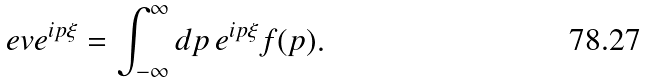Convert formula to latex. <formula><loc_0><loc_0><loc_500><loc_500>\ e v { e ^ { i p \xi } } = \int _ { - \infty } ^ { \infty } d p \, e ^ { i p \xi } f ( p ) .</formula> 